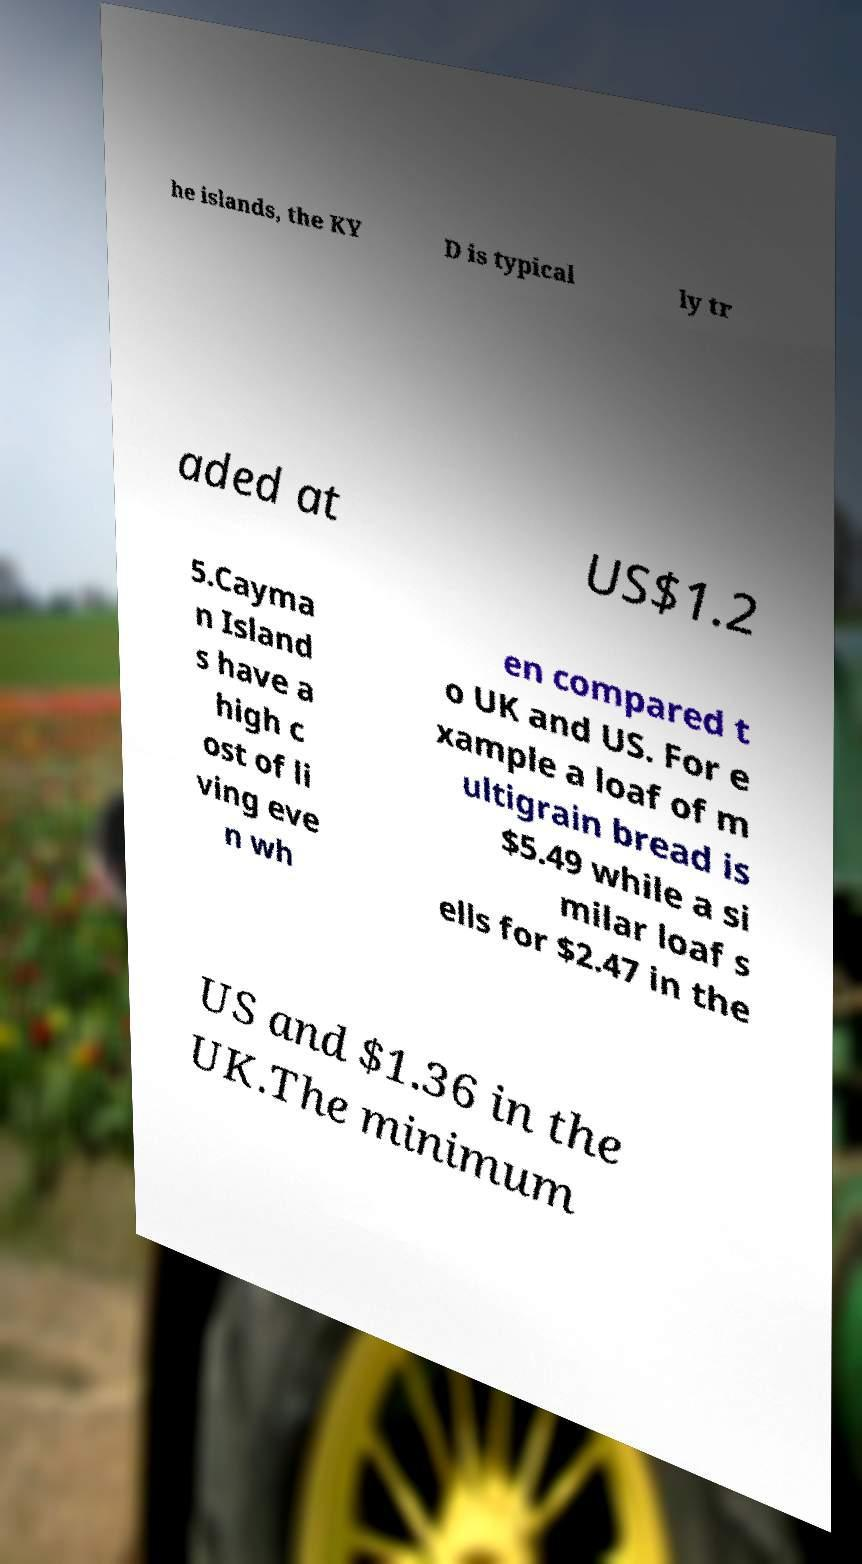I need the written content from this picture converted into text. Can you do that? he islands, the KY D is typical ly tr aded at US$1.2 5.Cayma n Island s have a high c ost of li ving eve n wh en compared t o UK and US. For e xample a loaf of m ultigrain bread is $5.49 while a si milar loaf s ells for $2.47 in the US and $1.36 in the UK.The minimum 